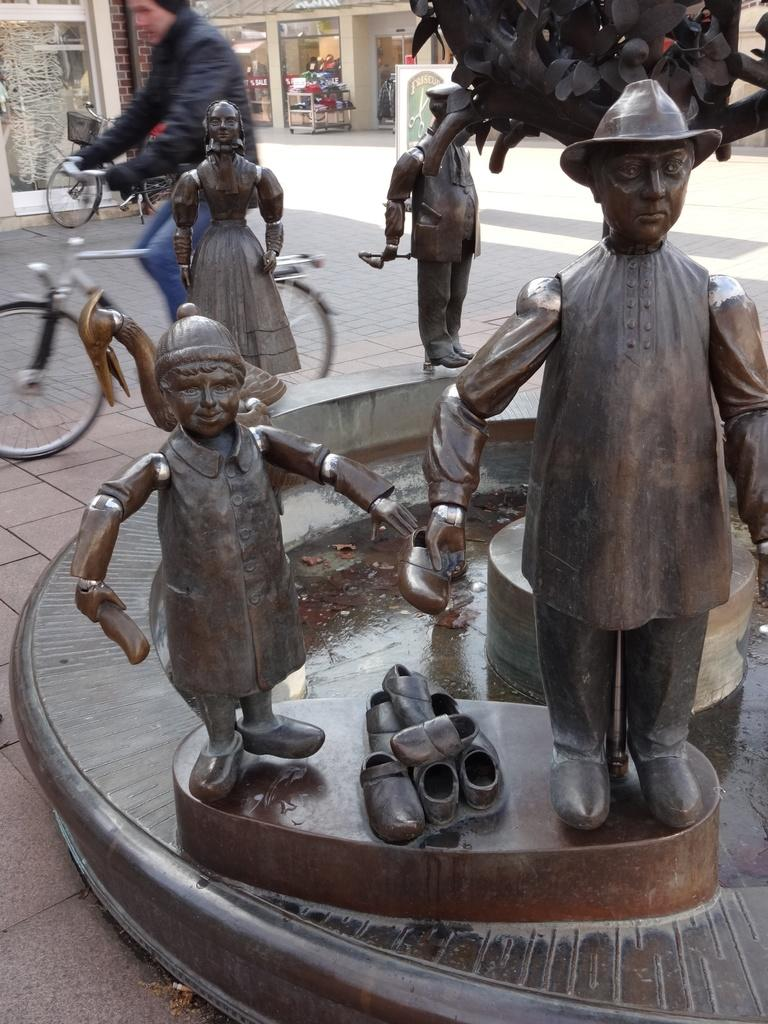What can be seen in the image that represents art or sculpture? There are statues in the image. What activity is the person in the image engaged in? The person in the image is riding a bicycle. What type of establishments can be seen in the background of the image? There are shops visible in the background of the image. How many apples are being carried by the person riding the bicycle in the image? There are no apples visible in the image; the person is riding a bicycle without any apples. What type of wall can be seen surrounding the area in the image? There is no wall visible in the image; it features statues, a person riding a bicycle, and shops in the background. 